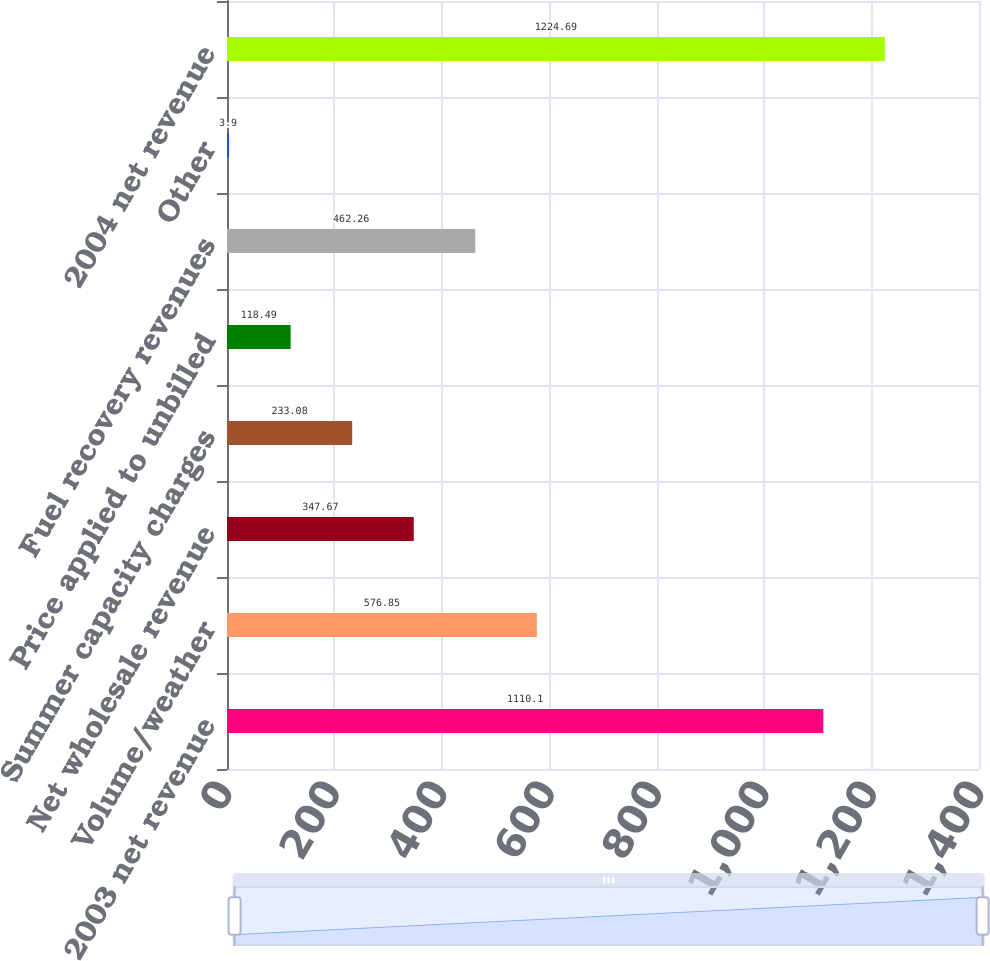<chart> <loc_0><loc_0><loc_500><loc_500><bar_chart><fcel>2003 net revenue<fcel>Volume/weather<fcel>Net wholesale revenue<fcel>Summer capacity charges<fcel>Price applied to unbilled<fcel>Fuel recovery revenues<fcel>Other<fcel>2004 net revenue<nl><fcel>1110.1<fcel>576.85<fcel>347.67<fcel>233.08<fcel>118.49<fcel>462.26<fcel>3.9<fcel>1224.69<nl></chart> 